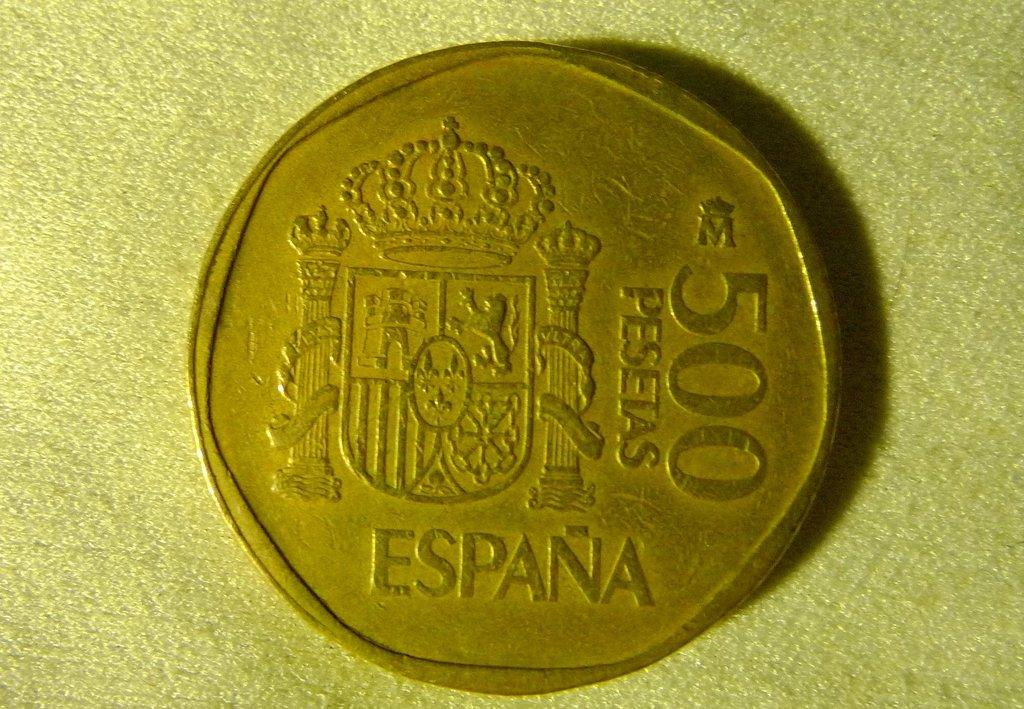Provide a one-sentence caption for the provided image. A coin reading 500 Pesetas sits on a cloth surface. 